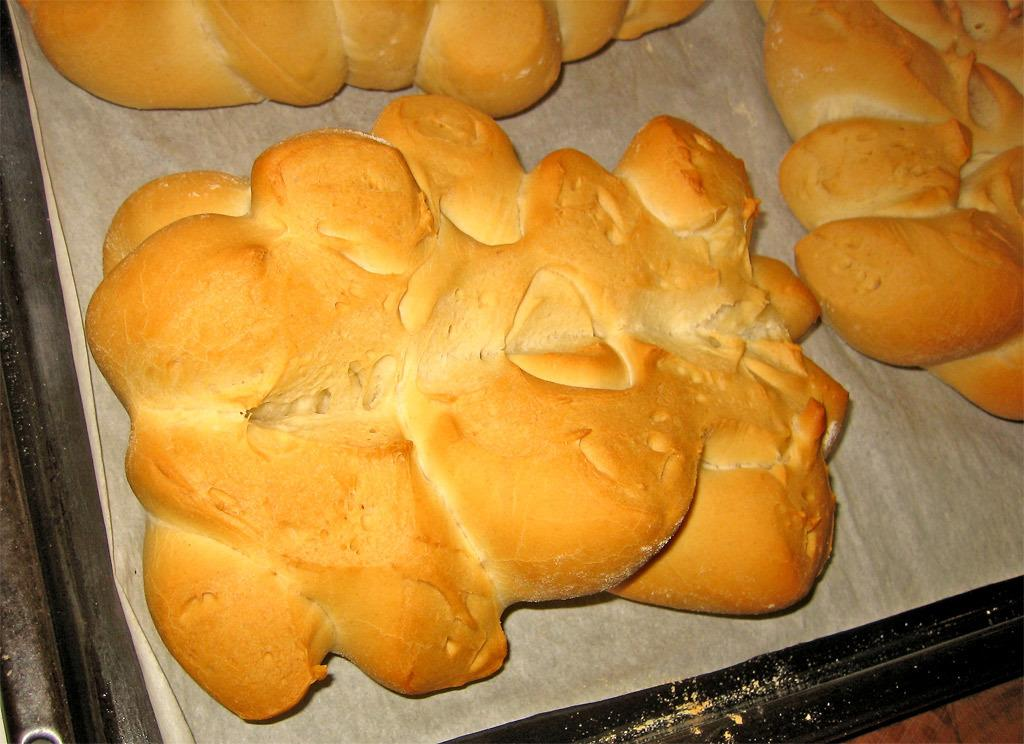What type of food can be seen in the image? There are baked items in the image. How are the baked items arranged or organized? The baked items are in a tray. Where is the tray with baked items located? The tray is on a table. How many beans are visible on the baked items in the image? There is no mention of beans in the image, as it features baked items in a tray on a table. 